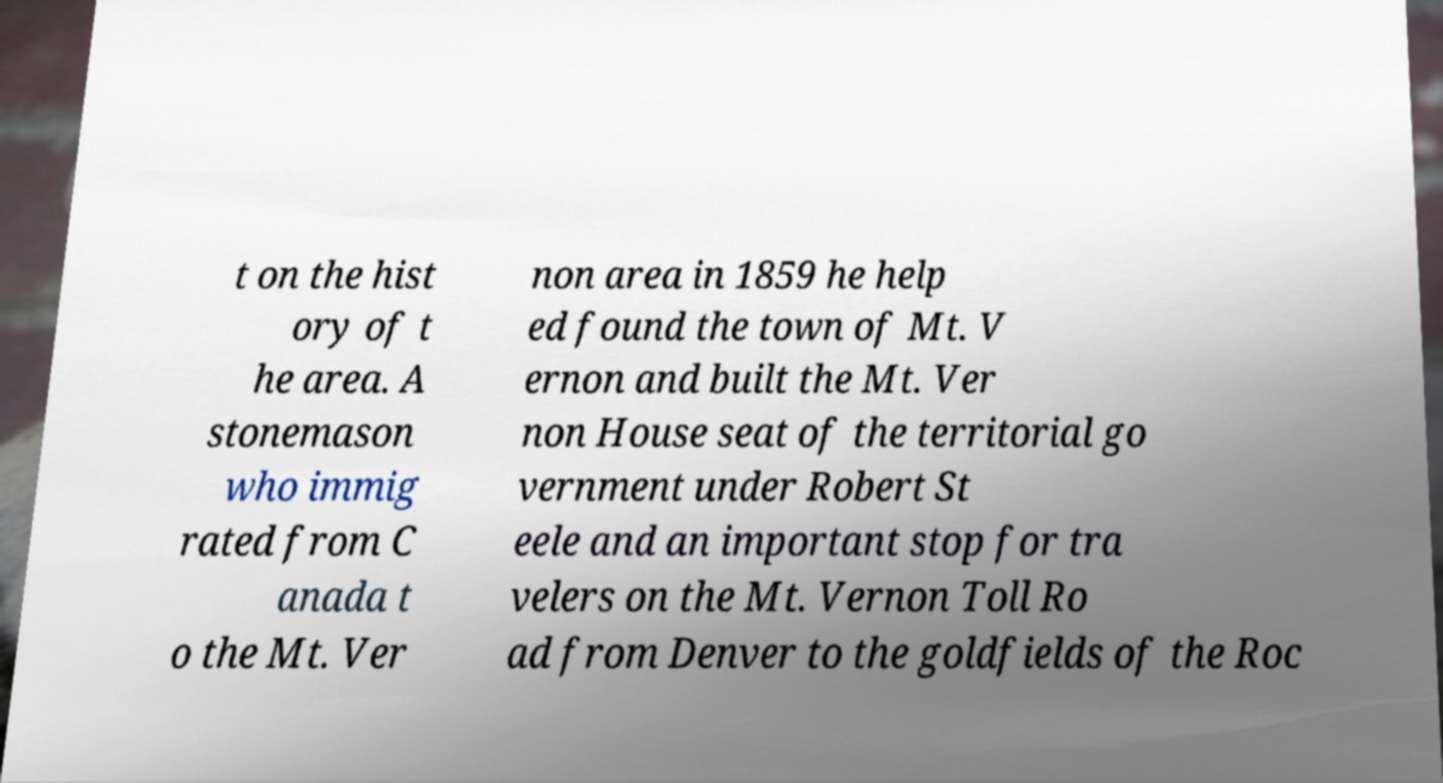For documentation purposes, I need the text within this image transcribed. Could you provide that? t on the hist ory of t he area. A stonemason who immig rated from C anada t o the Mt. Ver non area in 1859 he help ed found the town of Mt. V ernon and built the Mt. Ver non House seat of the territorial go vernment under Robert St eele and an important stop for tra velers on the Mt. Vernon Toll Ro ad from Denver to the goldfields of the Roc 